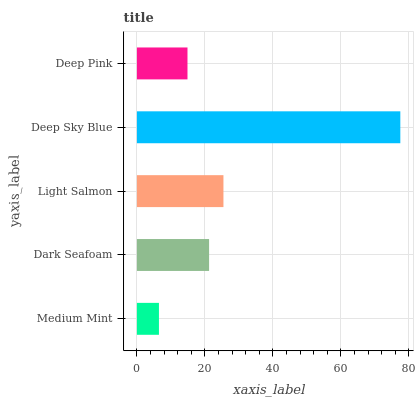Is Medium Mint the minimum?
Answer yes or no. Yes. Is Deep Sky Blue the maximum?
Answer yes or no. Yes. Is Dark Seafoam the minimum?
Answer yes or no. No. Is Dark Seafoam the maximum?
Answer yes or no. No. Is Dark Seafoam greater than Medium Mint?
Answer yes or no. Yes. Is Medium Mint less than Dark Seafoam?
Answer yes or no. Yes. Is Medium Mint greater than Dark Seafoam?
Answer yes or no. No. Is Dark Seafoam less than Medium Mint?
Answer yes or no. No. Is Dark Seafoam the high median?
Answer yes or no. Yes. Is Dark Seafoam the low median?
Answer yes or no. Yes. Is Deep Pink the high median?
Answer yes or no. No. Is Light Salmon the low median?
Answer yes or no. No. 